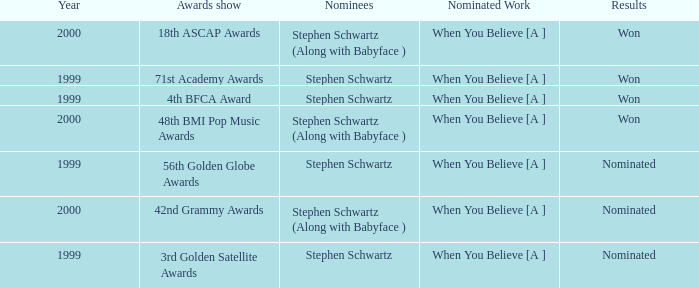Which Nominated Work won in 2000? When You Believe [A ], When You Believe [A ]. 